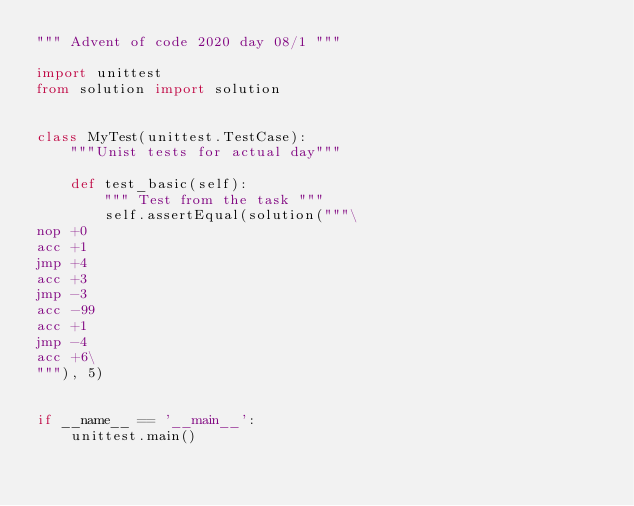Convert code to text. <code><loc_0><loc_0><loc_500><loc_500><_Python_>""" Advent of code 2020 day 08/1 """

import unittest
from solution import solution


class MyTest(unittest.TestCase):
    """Unist tests for actual day"""

    def test_basic(self):
        """ Test from the task """
        self.assertEqual(solution("""\
nop +0
acc +1
jmp +4
acc +3
jmp -3
acc -99
acc +1
jmp -4
acc +6\
"""), 5)


if __name__ == '__main__':
    unittest.main()
</code> 